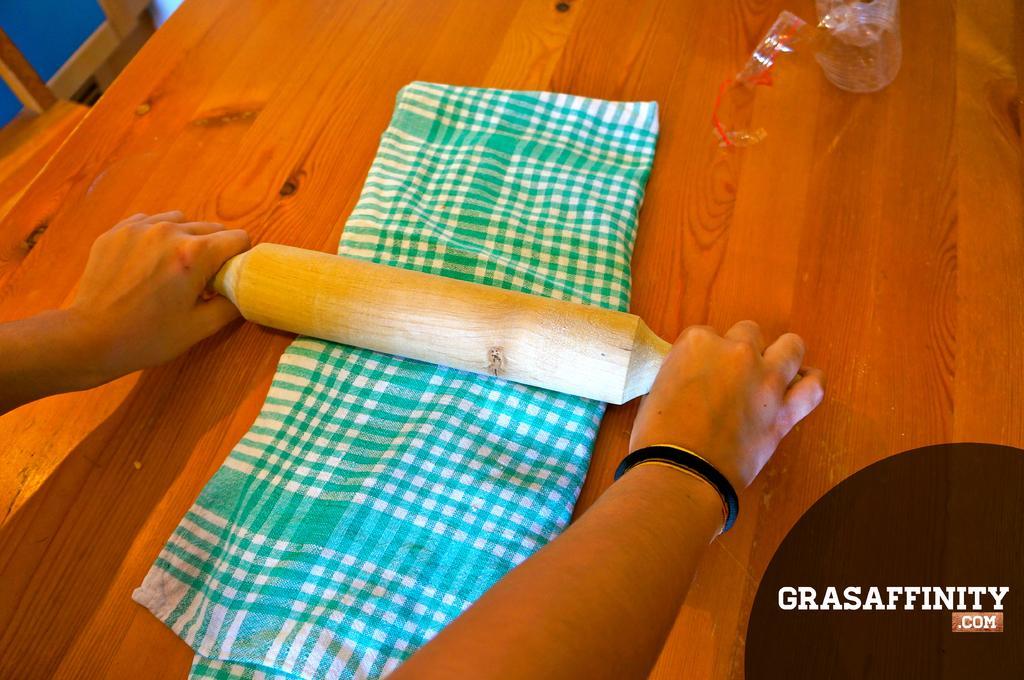Describe this image in one or two sentences. In the center of the image there is person's hand holding roti roller. There is a cloth on the table. 